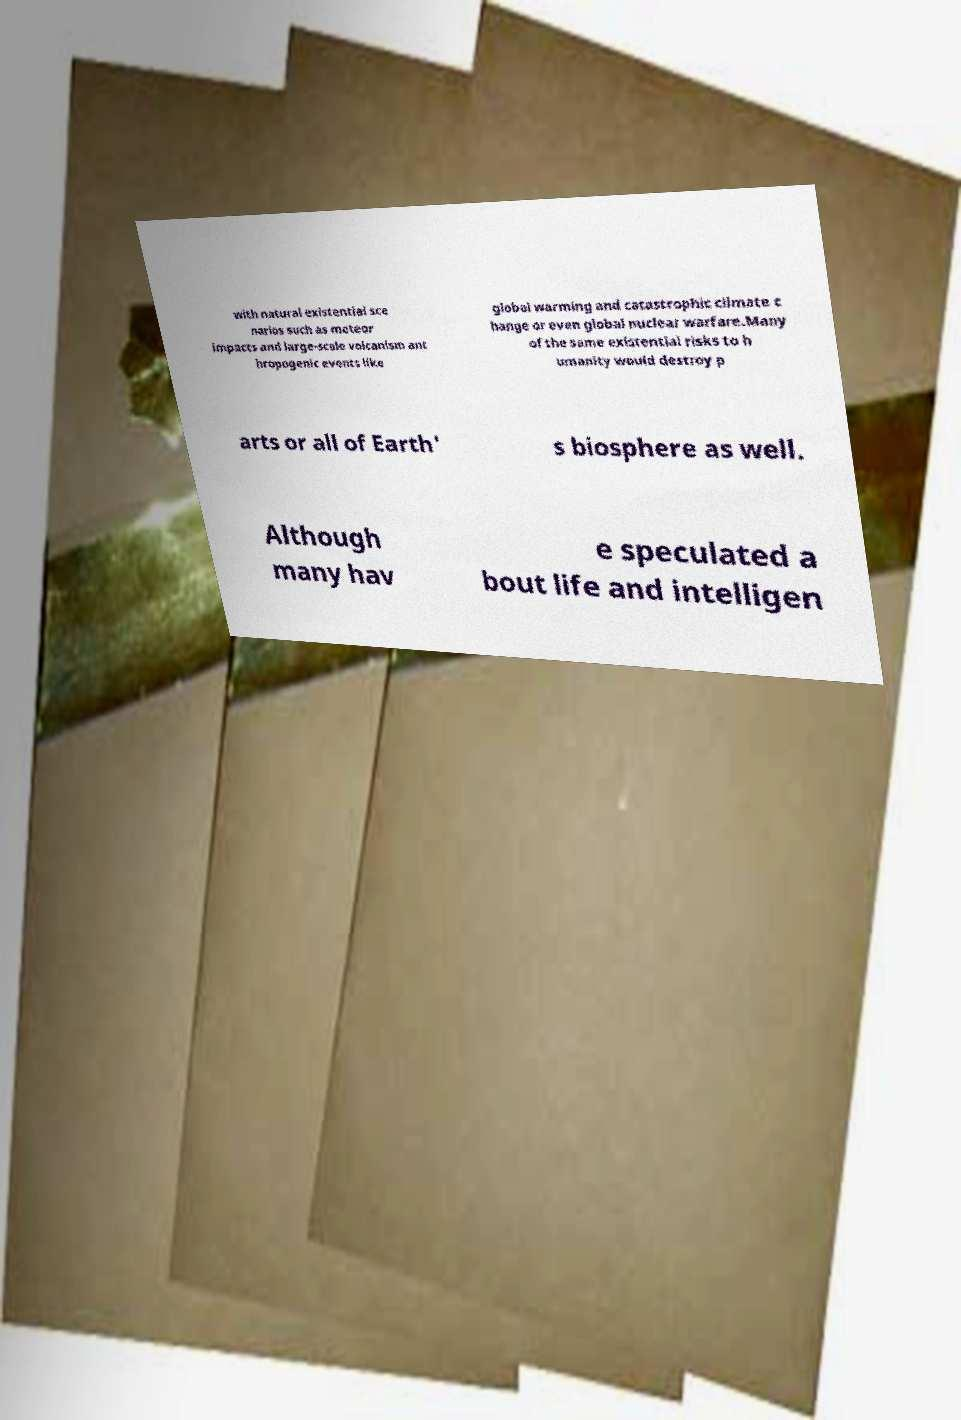Can you read and provide the text displayed in the image?This photo seems to have some interesting text. Can you extract and type it out for me? with natural existential sce narios such as meteor impacts and large-scale volcanism ant hropogenic events like global warming and catastrophic climate c hange or even global nuclear warfare.Many of the same existential risks to h umanity would destroy p arts or all of Earth' s biosphere as well. Although many hav e speculated a bout life and intelligen 